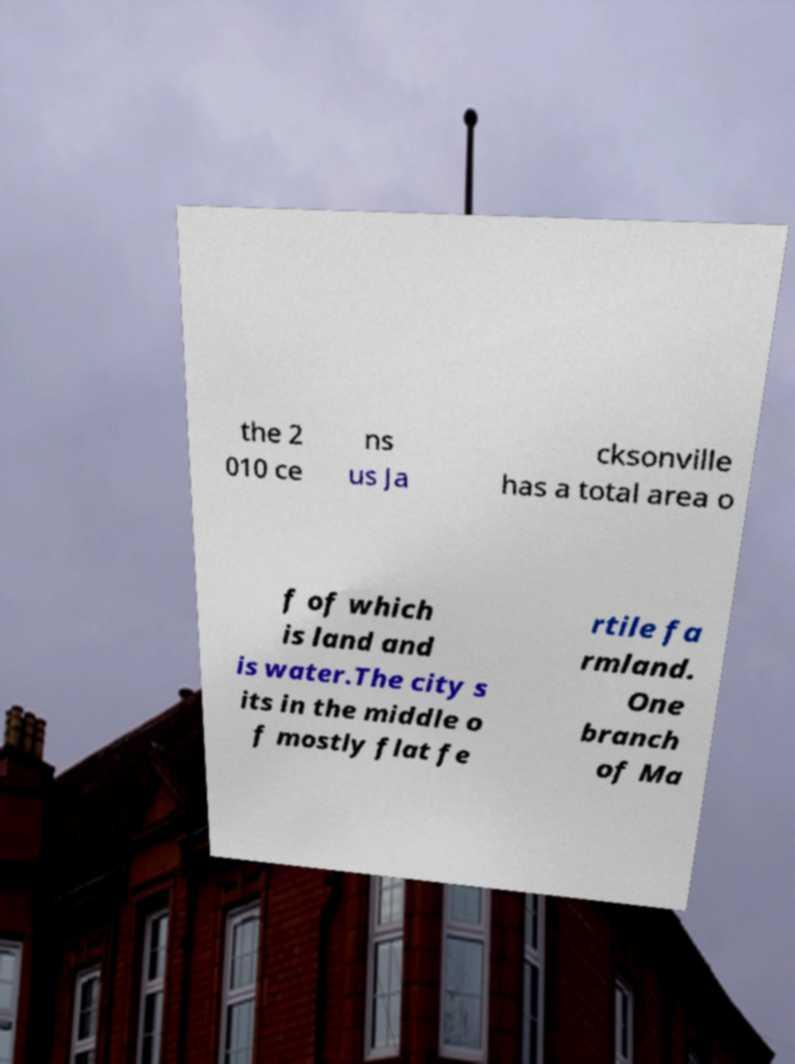I need the written content from this picture converted into text. Can you do that? the 2 010 ce ns us Ja cksonville has a total area o f of which is land and is water.The city s its in the middle o f mostly flat fe rtile fa rmland. One branch of Ma 